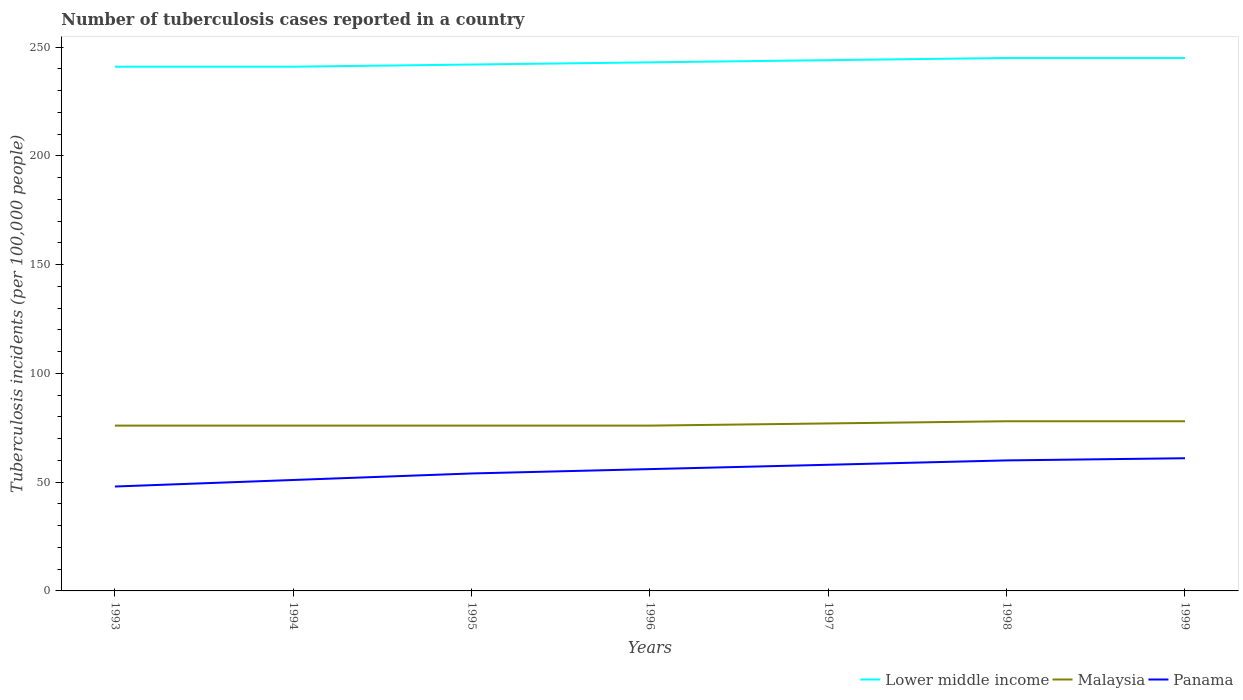Does the line corresponding to Panama intersect with the line corresponding to Malaysia?
Give a very brief answer. No. Across all years, what is the maximum number of tuberculosis cases reported in in Malaysia?
Offer a terse response. 76. In which year was the number of tuberculosis cases reported in in Panama maximum?
Offer a very short reply. 1993. What is the total number of tuberculosis cases reported in in Lower middle income in the graph?
Give a very brief answer. -3. What is the difference between the highest and the second highest number of tuberculosis cases reported in in Panama?
Ensure brevity in your answer.  13. What is the difference between the highest and the lowest number of tuberculosis cases reported in in Lower middle income?
Offer a very short reply. 3. Is the number of tuberculosis cases reported in in Malaysia strictly greater than the number of tuberculosis cases reported in in Panama over the years?
Your response must be concise. No. What is the difference between two consecutive major ticks on the Y-axis?
Offer a terse response. 50. Are the values on the major ticks of Y-axis written in scientific E-notation?
Offer a terse response. No. Does the graph contain any zero values?
Your answer should be very brief. No. Does the graph contain grids?
Ensure brevity in your answer.  No. How many legend labels are there?
Your response must be concise. 3. How are the legend labels stacked?
Provide a short and direct response. Horizontal. What is the title of the graph?
Offer a very short reply. Number of tuberculosis cases reported in a country. What is the label or title of the X-axis?
Provide a short and direct response. Years. What is the label or title of the Y-axis?
Make the answer very short. Tuberculosis incidents (per 100,0 people). What is the Tuberculosis incidents (per 100,000 people) in Lower middle income in 1993?
Make the answer very short. 241. What is the Tuberculosis incidents (per 100,000 people) of Panama in 1993?
Provide a short and direct response. 48. What is the Tuberculosis incidents (per 100,000 people) of Lower middle income in 1994?
Your answer should be compact. 241. What is the Tuberculosis incidents (per 100,000 people) in Lower middle income in 1995?
Offer a terse response. 242. What is the Tuberculosis incidents (per 100,000 people) in Malaysia in 1995?
Offer a very short reply. 76. What is the Tuberculosis incidents (per 100,000 people) of Lower middle income in 1996?
Ensure brevity in your answer.  243. What is the Tuberculosis incidents (per 100,000 people) of Malaysia in 1996?
Offer a very short reply. 76. What is the Tuberculosis incidents (per 100,000 people) in Lower middle income in 1997?
Give a very brief answer. 244. What is the Tuberculosis incidents (per 100,000 people) in Panama in 1997?
Your answer should be very brief. 58. What is the Tuberculosis incidents (per 100,000 people) in Lower middle income in 1998?
Provide a short and direct response. 245. What is the Tuberculosis incidents (per 100,000 people) in Malaysia in 1998?
Offer a very short reply. 78. What is the Tuberculosis incidents (per 100,000 people) in Lower middle income in 1999?
Your answer should be compact. 245. What is the Tuberculosis incidents (per 100,000 people) of Panama in 1999?
Your answer should be compact. 61. Across all years, what is the maximum Tuberculosis incidents (per 100,000 people) of Lower middle income?
Keep it short and to the point. 245. Across all years, what is the minimum Tuberculosis incidents (per 100,000 people) of Lower middle income?
Offer a very short reply. 241. Across all years, what is the minimum Tuberculosis incidents (per 100,000 people) of Malaysia?
Provide a short and direct response. 76. Across all years, what is the minimum Tuberculosis incidents (per 100,000 people) in Panama?
Make the answer very short. 48. What is the total Tuberculosis incidents (per 100,000 people) of Lower middle income in the graph?
Provide a short and direct response. 1701. What is the total Tuberculosis incidents (per 100,000 people) in Malaysia in the graph?
Offer a very short reply. 537. What is the total Tuberculosis incidents (per 100,000 people) of Panama in the graph?
Give a very brief answer. 388. What is the difference between the Tuberculosis incidents (per 100,000 people) in Lower middle income in 1993 and that in 1994?
Make the answer very short. 0. What is the difference between the Tuberculosis incidents (per 100,000 people) of Malaysia in 1993 and that in 1994?
Your response must be concise. 0. What is the difference between the Tuberculosis incidents (per 100,000 people) in Malaysia in 1993 and that in 1995?
Give a very brief answer. 0. What is the difference between the Tuberculosis incidents (per 100,000 people) in Panama in 1993 and that in 1995?
Provide a short and direct response. -6. What is the difference between the Tuberculosis incidents (per 100,000 people) of Malaysia in 1993 and that in 1996?
Offer a very short reply. 0. What is the difference between the Tuberculosis incidents (per 100,000 people) in Lower middle income in 1993 and that in 1997?
Offer a very short reply. -3. What is the difference between the Tuberculosis incidents (per 100,000 people) of Malaysia in 1993 and that in 1997?
Keep it short and to the point. -1. What is the difference between the Tuberculosis incidents (per 100,000 people) in Malaysia in 1993 and that in 1998?
Offer a very short reply. -2. What is the difference between the Tuberculosis incidents (per 100,000 people) in Lower middle income in 1993 and that in 1999?
Provide a succinct answer. -4. What is the difference between the Tuberculosis incidents (per 100,000 people) of Malaysia in 1993 and that in 1999?
Offer a very short reply. -2. What is the difference between the Tuberculosis incidents (per 100,000 people) of Panama in 1993 and that in 1999?
Keep it short and to the point. -13. What is the difference between the Tuberculosis incidents (per 100,000 people) of Panama in 1994 and that in 1995?
Provide a succinct answer. -3. What is the difference between the Tuberculosis incidents (per 100,000 people) of Lower middle income in 1994 and that in 1996?
Your answer should be very brief. -2. What is the difference between the Tuberculosis incidents (per 100,000 people) in Malaysia in 1994 and that in 1996?
Give a very brief answer. 0. What is the difference between the Tuberculosis incidents (per 100,000 people) of Panama in 1994 and that in 1997?
Offer a very short reply. -7. What is the difference between the Tuberculosis incidents (per 100,000 people) of Panama in 1994 and that in 1999?
Offer a terse response. -10. What is the difference between the Tuberculosis incidents (per 100,000 people) of Malaysia in 1995 and that in 1996?
Provide a succinct answer. 0. What is the difference between the Tuberculosis incidents (per 100,000 people) in Lower middle income in 1995 and that in 1997?
Provide a short and direct response. -2. What is the difference between the Tuberculosis incidents (per 100,000 people) in Panama in 1995 and that in 1997?
Offer a terse response. -4. What is the difference between the Tuberculosis incidents (per 100,000 people) of Lower middle income in 1995 and that in 1998?
Your answer should be very brief. -3. What is the difference between the Tuberculosis incidents (per 100,000 people) of Malaysia in 1995 and that in 1998?
Your response must be concise. -2. What is the difference between the Tuberculosis incidents (per 100,000 people) of Lower middle income in 1995 and that in 1999?
Provide a short and direct response. -3. What is the difference between the Tuberculosis incidents (per 100,000 people) of Panama in 1995 and that in 1999?
Ensure brevity in your answer.  -7. What is the difference between the Tuberculosis incidents (per 100,000 people) of Lower middle income in 1996 and that in 1997?
Your answer should be compact. -1. What is the difference between the Tuberculosis incidents (per 100,000 people) in Lower middle income in 1996 and that in 1998?
Make the answer very short. -2. What is the difference between the Tuberculosis incidents (per 100,000 people) in Malaysia in 1996 and that in 1998?
Provide a succinct answer. -2. What is the difference between the Tuberculosis incidents (per 100,000 people) of Panama in 1996 and that in 1998?
Keep it short and to the point. -4. What is the difference between the Tuberculosis incidents (per 100,000 people) in Lower middle income in 1996 and that in 1999?
Your answer should be compact. -2. What is the difference between the Tuberculosis incidents (per 100,000 people) of Malaysia in 1996 and that in 1999?
Your answer should be compact. -2. What is the difference between the Tuberculosis incidents (per 100,000 people) of Panama in 1996 and that in 1999?
Your response must be concise. -5. What is the difference between the Tuberculosis incidents (per 100,000 people) in Lower middle income in 1997 and that in 1998?
Give a very brief answer. -1. What is the difference between the Tuberculosis incidents (per 100,000 people) of Malaysia in 1997 and that in 1999?
Give a very brief answer. -1. What is the difference between the Tuberculosis incidents (per 100,000 people) in Panama in 1997 and that in 1999?
Ensure brevity in your answer.  -3. What is the difference between the Tuberculosis incidents (per 100,000 people) of Lower middle income in 1998 and that in 1999?
Your answer should be very brief. 0. What is the difference between the Tuberculosis incidents (per 100,000 people) in Malaysia in 1998 and that in 1999?
Offer a terse response. 0. What is the difference between the Tuberculosis incidents (per 100,000 people) in Lower middle income in 1993 and the Tuberculosis incidents (per 100,000 people) in Malaysia in 1994?
Your response must be concise. 165. What is the difference between the Tuberculosis incidents (per 100,000 people) in Lower middle income in 1993 and the Tuberculosis incidents (per 100,000 people) in Panama in 1994?
Offer a very short reply. 190. What is the difference between the Tuberculosis incidents (per 100,000 people) in Malaysia in 1993 and the Tuberculosis incidents (per 100,000 people) in Panama in 1994?
Keep it short and to the point. 25. What is the difference between the Tuberculosis incidents (per 100,000 people) of Lower middle income in 1993 and the Tuberculosis incidents (per 100,000 people) of Malaysia in 1995?
Give a very brief answer. 165. What is the difference between the Tuberculosis incidents (per 100,000 people) of Lower middle income in 1993 and the Tuberculosis incidents (per 100,000 people) of Panama in 1995?
Provide a succinct answer. 187. What is the difference between the Tuberculosis incidents (per 100,000 people) of Malaysia in 1993 and the Tuberculosis incidents (per 100,000 people) of Panama in 1995?
Offer a very short reply. 22. What is the difference between the Tuberculosis incidents (per 100,000 people) in Lower middle income in 1993 and the Tuberculosis incidents (per 100,000 people) in Malaysia in 1996?
Offer a very short reply. 165. What is the difference between the Tuberculosis incidents (per 100,000 people) of Lower middle income in 1993 and the Tuberculosis incidents (per 100,000 people) of Panama in 1996?
Provide a short and direct response. 185. What is the difference between the Tuberculosis incidents (per 100,000 people) of Lower middle income in 1993 and the Tuberculosis incidents (per 100,000 people) of Malaysia in 1997?
Offer a very short reply. 164. What is the difference between the Tuberculosis incidents (per 100,000 people) of Lower middle income in 1993 and the Tuberculosis incidents (per 100,000 people) of Panama in 1997?
Your answer should be very brief. 183. What is the difference between the Tuberculosis incidents (per 100,000 people) in Lower middle income in 1993 and the Tuberculosis incidents (per 100,000 people) in Malaysia in 1998?
Your answer should be very brief. 163. What is the difference between the Tuberculosis incidents (per 100,000 people) of Lower middle income in 1993 and the Tuberculosis incidents (per 100,000 people) of Panama in 1998?
Make the answer very short. 181. What is the difference between the Tuberculosis incidents (per 100,000 people) in Malaysia in 1993 and the Tuberculosis incidents (per 100,000 people) in Panama in 1998?
Your answer should be very brief. 16. What is the difference between the Tuberculosis incidents (per 100,000 people) in Lower middle income in 1993 and the Tuberculosis incidents (per 100,000 people) in Malaysia in 1999?
Give a very brief answer. 163. What is the difference between the Tuberculosis incidents (per 100,000 people) in Lower middle income in 1993 and the Tuberculosis incidents (per 100,000 people) in Panama in 1999?
Your answer should be very brief. 180. What is the difference between the Tuberculosis incidents (per 100,000 people) in Malaysia in 1993 and the Tuberculosis incidents (per 100,000 people) in Panama in 1999?
Offer a very short reply. 15. What is the difference between the Tuberculosis incidents (per 100,000 people) of Lower middle income in 1994 and the Tuberculosis incidents (per 100,000 people) of Malaysia in 1995?
Provide a short and direct response. 165. What is the difference between the Tuberculosis incidents (per 100,000 people) of Lower middle income in 1994 and the Tuberculosis incidents (per 100,000 people) of Panama in 1995?
Give a very brief answer. 187. What is the difference between the Tuberculosis incidents (per 100,000 people) of Lower middle income in 1994 and the Tuberculosis incidents (per 100,000 people) of Malaysia in 1996?
Give a very brief answer. 165. What is the difference between the Tuberculosis incidents (per 100,000 people) in Lower middle income in 1994 and the Tuberculosis incidents (per 100,000 people) in Panama in 1996?
Keep it short and to the point. 185. What is the difference between the Tuberculosis incidents (per 100,000 people) of Lower middle income in 1994 and the Tuberculosis incidents (per 100,000 people) of Malaysia in 1997?
Offer a terse response. 164. What is the difference between the Tuberculosis incidents (per 100,000 people) in Lower middle income in 1994 and the Tuberculosis incidents (per 100,000 people) in Panama in 1997?
Keep it short and to the point. 183. What is the difference between the Tuberculosis incidents (per 100,000 people) of Lower middle income in 1994 and the Tuberculosis incidents (per 100,000 people) of Malaysia in 1998?
Provide a short and direct response. 163. What is the difference between the Tuberculosis incidents (per 100,000 people) of Lower middle income in 1994 and the Tuberculosis incidents (per 100,000 people) of Panama in 1998?
Make the answer very short. 181. What is the difference between the Tuberculosis incidents (per 100,000 people) in Lower middle income in 1994 and the Tuberculosis incidents (per 100,000 people) in Malaysia in 1999?
Your answer should be very brief. 163. What is the difference between the Tuberculosis incidents (per 100,000 people) of Lower middle income in 1994 and the Tuberculosis incidents (per 100,000 people) of Panama in 1999?
Your response must be concise. 180. What is the difference between the Tuberculosis incidents (per 100,000 people) in Malaysia in 1994 and the Tuberculosis incidents (per 100,000 people) in Panama in 1999?
Offer a terse response. 15. What is the difference between the Tuberculosis incidents (per 100,000 people) of Lower middle income in 1995 and the Tuberculosis incidents (per 100,000 people) of Malaysia in 1996?
Make the answer very short. 166. What is the difference between the Tuberculosis incidents (per 100,000 people) in Lower middle income in 1995 and the Tuberculosis incidents (per 100,000 people) in Panama in 1996?
Offer a terse response. 186. What is the difference between the Tuberculosis incidents (per 100,000 people) in Lower middle income in 1995 and the Tuberculosis incidents (per 100,000 people) in Malaysia in 1997?
Your response must be concise. 165. What is the difference between the Tuberculosis incidents (per 100,000 people) in Lower middle income in 1995 and the Tuberculosis incidents (per 100,000 people) in Panama in 1997?
Your response must be concise. 184. What is the difference between the Tuberculosis incidents (per 100,000 people) of Lower middle income in 1995 and the Tuberculosis incidents (per 100,000 people) of Malaysia in 1998?
Ensure brevity in your answer.  164. What is the difference between the Tuberculosis incidents (per 100,000 people) of Lower middle income in 1995 and the Tuberculosis incidents (per 100,000 people) of Panama in 1998?
Your answer should be very brief. 182. What is the difference between the Tuberculosis incidents (per 100,000 people) in Malaysia in 1995 and the Tuberculosis incidents (per 100,000 people) in Panama in 1998?
Your answer should be compact. 16. What is the difference between the Tuberculosis incidents (per 100,000 people) of Lower middle income in 1995 and the Tuberculosis incidents (per 100,000 people) of Malaysia in 1999?
Offer a very short reply. 164. What is the difference between the Tuberculosis incidents (per 100,000 people) in Lower middle income in 1995 and the Tuberculosis incidents (per 100,000 people) in Panama in 1999?
Provide a succinct answer. 181. What is the difference between the Tuberculosis incidents (per 100,000 people) of Malaysia in 1995 and the Tuberculosis incidents (per 100,000 people) of Panama in 1999?
Offer a very short reply. 15. What is the difference between the Tuberculosis incidents (per 100,000 people) in Lower middle income in 1996 and the Tuberculosis incidents (per 100,000 people) in Malaysia in 1997?
Your answer should be very brief. 166. What is the difference between the Tuberculosis incidents (per 100,000 people) in Lower middle income in 1996 and the Tuberculosis incidents (per 100,000 people) in Panama in 1997?
Keep it short and to the point. 185. What is the difference between the Tuberculosis incidents (per 100,000 people) of Lower middle income in 1996 and the Tuberculosis incidents (per 100,000 people) of Malaysia in 1998?
Ensure brevity in your answer.  165. What is the difference between the Tuberculosis incidents (per 100,000 people) of Lower middle income in 1996 and the Tuberculosis incidents (per 100,000 people) of Panama in 1998?
Offer a very short reply. 183. What is the difference between the Tuberculosis incidents (per 100,000 people) in Malaysia in 1996 and the Tuberculosis incidents (per 100,000 people) in Panama in 1998?
Offer a terse response. 16. What is the difference between the Tuberculosis incidents (per 100,000 people) of Lower middle income in 1996 and the Tuberculosis incidents (per 100,000 people) of Malaysia in 1999?
Offer a terse response. 165. What is the difference between the Tuberculosis incidents (per 100,000 people) in Lower middle income in 1996 and the Tuberculosis incidents (per 100,000 people) in Panama in 1999?
Offer a very short reply. 182. What is the difference between the Tuberculosis incidents (per 100,000 people) in Lower middle income in 1997 and the Tuberculosis incidents (per 100,000 people) in Malaysia in 1998?
Give a very brief answer. 166. What is the difference between the Tuberculosis incidents (per 100,000 people) in Lower middle income in 1997 and the Tuberculosis incidents (per 100,000 people) in Panama in 1998?
Offer a terse response. 184. What is the difference between the Tuberculosis incidents (per 100,000 people) of Malaysia in 1997 and the Tuberculosis incidents (per 100,000 people) of Panama in 1998?
Ensure brevity in your answer.  17. What is the difference between the Tuberculosis incidents (per 100,000 people) in Lower middle income in 1997 and the Tuberculosis incidents (per 100,000 people) in Malaysia in 1999?
Provide a succinct answer. 166. What is the difference between the Tuberculosis incidents (per 100,000 people) of Lower middle income in 1997 and the Tuberculosis incidents (per 100,000 people) of Panama in 1999?
Your answer should be compact. 183. What is the difference between the Tuberculosis incidents (per 100,000 people) in Lower middle income in 1998 and the Tuberculosis incidents (per 100,000 people) in Malaysia in 1999?
Keep it short and to the point. 167. What is the difference between the Tuberculosis incidents (per 100,000 people) in Lower middle income in 1998 and the Tuberculosis incidents (per 100,000 people) in Panama in 1999?
Your answer should be very brief. 184. What is the difference between the Tuberculosis incidents (per 100,000 people) in Malaysia in 1998 and the Tuberculosis incidents (per 100,000 people) in Panama in 1999?
Offer a very short reply. 17. What is the average Tuberculosis incidents (per 100,000 people) of Lower middle income per year?
Keep it short and to the point. 243. What is the average Tuberculosis incidents (per 100,000 people) of Malaysia per year?
Your response must be concise. 76.71. What is the average Tuberculosis incidents (per 100,000 people) in Panama per year?
Make the answer very short. 55.43. In the year 1993, what is the difference between the Tuberculosis incidents (per 100,000 people) of Lower middle income and Tuberculosis incidents (per 100,000 people) of Malaysia?
Give a very brief answer. 165. In the year 1993, what is the difference between the Tuberculosis incidents (per 100,000 people) of Lower middle income and Tuberculosis incidents (per 100,000 people) of Panama?
Provide a succinct answer. 193. In the year 1993, what is the difference between the Tuberculosis incidents (per 100,000 people) in Malaysia and Tuberculosis incidents (per 100,000 people) in Panama?
Your answer should be compact. 28. In the year 1994, what is the difference between the Tuberculosis incidents (per 100,000 people) in Lower middle income and Tuberculosis incidents (per 100,000 people) in Malaysia?
Offer a terse response. 165. In the year 1994, what is the difference between the Tuberculosis incidents (per 100,000 people) in Lower middle income and Tuberculosis incidents (per 100,000 people) in Panama?
Offer a very short reply. 190. In the year 1995, what is the difference between the Tuberculosis incidents (per 100,000 people) of Lower middle income and Tuberculosis incidents (per 100,000 people) of Malaysia?
Provide a succinct answer. 166. In the year 1995, what is the difference between the Tuberculosis incidents (per 100,000 people) in Lower middle income and Tuberculosis incidents (per 100,000 people) in Panama?
Your answer should be very brief. 188. In the year 1995, what is the difference between the Tuberculosis incidents (per 100,000 people) of Malaysia and Tuberculosis incidents (per 100,000 people) of Panama?
Your answer should be compact. 22. In the year 1996, what is the difference between the Tuberculosis incidents (per 100,000 people) in Lower middle income and Tuberculosis incidents (per 100,000 people) in Malaysia?
Your answer should be very brief. 167. In the year 1996, what is the difference between the Tuberculosis incidents (per 100,000 people) of Lower middle income and Tuberculosis incidents (per 100,000 people) of Panama?
Offer a very short reply. 187. In the year 1996, what is the difference between the Tuberculosis incidents (per 100,000 people) in Malaysia and Tuberculosis incidents (per 100,000 people) in Panama?
Provide a succinct answer. 20. In the year 1997, what is the difference between the Tuberculosis incidents (per 100,000 people) of Lower middle income and Tuberculosis incidents (per 100,000 people) of Malaysia?
Provide a short and direct response. 167. In the year 1997, what is the difference between the Tuberculosis incidents (per 100,000 people) of Lower middle income and Tuberculosis incidents (per 100,000 people) of Panama?
Your answer should be very brief. 186. In the year 1997, what is the difference between the Tuberculosis incidents (per 100,000 people) of Malaysia and Tuberculosis incidents (per 100,000 people) of Panama?
Your response must be concise. 19. In the year 1998, what is the difference between the Tuberculosis incidents (per 100,000 people) of Lower middle income and Tuberculosis incidents (per 100,000 people) of Malaysia?
Provide a short and direct response. 167. In the year 1998, what is the difference between the Tuberculosis incidents (per 100,000 people) in Lower middle income and Tuberculosis incidents (per 100,000 people) in Panama?
Your answer should be very brief. 185. In the year 1999, what is the difference between the Tuberculosis incidents (per 100,000 people) of Lower middle income and Tuberculosis incidents (per 100,000 people) of Malaysia?
Your answer should be compact. 167. In the year 1999, what is the difference between the Tuberculosis incidents (per 100,000 people) in Lower middle income and Tuberculosis incidents (per 100,000 people) in Panama?
Offer a terse response. 184. In the year 1999, what is the difference between the Tuberculosis incidents (per 100,000 people) of Malaysia and Tuberculosis incidents (per 100,000 people) of Panama?
Give a very brief answer. 17. What is the ratio of the Tuberculosis incidents (per 100,000 people) in Lower middle income in 1993 to that in 1994?
Keep it short and to the point. 1. What is the ratio of the Tuberculosis incidents (per 100,000 people) in Malaysia in 1993 to that in 1994?
Your answer should be very brief. 1. What is the ratio of the Tuberculosis incidents (per 100,000 people) in Panama in 1993 to that in 1994?
Your response must be concise. 0.94. What is the ratio of the Tuberculosis incidents (per 100,000 people) in Lower middle income in 1993 to that in 1995?
Offer a terse response. 1. What is the ratio of the Tuberculosis incidents (per 100,000 people) in Panama in 1993 to that in 1995?
Provide a succinct answer. 0.89. What is the ratio of the Tuberculosis incidents (per 100,000 people) in Panama in 1993 to that in 1996?
Provide a short and direct response. 0.86. What is the ratio of the Tuberculosis incidents (per 100,000 people) in Lower middle income in 1993 to that in 1997?
Keep it short and to the point. 0.99. What is the ratio of the Tuberculosis incidents (per 100,000 people) of Malaysia in 1993 to that in 1997?
Ensure brevity in your answer.  0.99. What is the ratio of the Tuberculosis incidents (per 100,000 people) of Panama in 1993 to that in 1997?
Offer a terse response. 0.83. What is the ratio of the Tuberculosis incidents (per 100,000 people) in Lower middle income in 1993 to that in 1998?
Your response must be concise. 0.98. What is the ratio of the Tuberculosis incidents (per 100,000 people) in Malaysia in 1993 to that in 1998?
Make the answer very short. 0.97. What is the ratio of the Tuberculosis incidents (per 100,000 people) in Lower middle income in 1993 to that in 1999?
Your answer should be very brief. 0.98. What is the ratio of the Tuberculosis incidents (per 100,000 people) in Malaysia in 1993 to that in 1999?
Offer a terse response. 0.97. What is the ratio of the Tuberculosis incidents (per 100,000 people) of Panama in 1993 to that in 1999?
Offer a terse response. 0.79. What is the ratio of the Tuberculosis incidents (per 100,000 people) of Lower middle income in 1994 to that in 1995?
Offer a terse response. 1. What is the ratio of the Tuberculosis incidents (per 100,000 people) in Panama in 1994 to that in 1995?
Give a very brief answer. 0.94. What is the ratio of the Tuberculosis incidents (per 100,000 people) of Lower middle income in 1994 to that in 1996?
Ensure brevity in your answer.  0.99. What is the ratio of the Tuberculosis incidents (per 100,000 people) in Panama in 1994 to that in 1996?
Give a very brief answer. 0.91. What is the ratio of the Tuberculosis incidents (per 100,000 people) of Panama in 1994 to that in 1997?
Ensure brevity in your answer.  0.88. What is the ratio of the Tuberculosis incidents (per 100,000 people) in Lower middle income in 1994 to that in 1998?
Make the answer very short. 0.98. What is the ratio of the Tuberculosis incidents (per 100,000 people) in Malaysia in 1994 to that in 1998?
Provide a short and direct response. 0.97. What is the ratio of the Tuberculosis incidents (per 100,000 people) of Lower middle income in 1994 to that in 1999?
Your answer should be compact. 0.98. What is the ratio of the Tuberculosis incidents (per 100,000 people) of Malaysia in 1994 to that in 1999?
Offer a terse response. 0.97. What is the ratio of the Tuberculosis incidents (per 100,000 people) in Panama in 1994 to that in 1999?
Give a very brief answer. 0.84. What is the ratio of the Tuberculosis incidents (per 100,000 people) in Panama in 1995 to that in 1996?
Keep it short and to the point. 0.96. What is the ratio of the Tuberculosis incidents (per 100,000 people) in Lower middle income in 1995 to that in 1997?
Your answer should be very brief. 0.99. What is the ratio of the Tuberculosis incidents (per 100,000 people) in Panama in 1995 to that in 1997?
Provide a short and direct response. 0.93. What is the ratio of the Tuberculosis incidents (per 100,000 people) of Lower middle income in 1995 to that in 1998?
Make the answer very short. 0.99. What is the ratio of the Tuberculosis incidents (per 100,000 people) of Malaysia in 1995 to that in 1998?
Provide a succinct answer. 0.97. What is the ratio of the Tuberculosis incidents (per 100,000 people) of Panama in 1995 to that in 1998?
Offer a terse response. 0.9. What is the ratio of the Tuberculosis incidents (per 100,000 people) of Lower middle income in 1995 to that in 1999?
Your answer should be very brief. 0.99. What is the ratio of the Tuberculosis incidents (per 100,000 people) of Malaysia in 1995 to that in 1999?
Your response must be concise. 0.97. What is the ratio of the Tuberculosis incidents (per 100,000 people) in Panama in 1995 to that in 1999?
Give a very brief answer. 0.89. What is the ratio of the Tuberculosis incidents (per 100,000 people) of Lower middle income in 1996 to that in 1997?
Provide a succinct answer. 1. What is the ratio of the Tuberculosis incidents (per 100,000 people) in Malaysia in 1996 to that in 1997?
Offer a very short reply. 0.99. What is the ratio of the Tuberculosis incidents (per 100,000 people) of Panama in 1996 to that in 1997?
Offer a terse response. 0.97. What is the ratio of the Tuberculosis incidents (per 100,000 people) of Malaysia in 1996 to that in 1998?
Give a very brief answer. 0.97. What is the ratio of the Tuberculosis incidents (per 100,000 people) in Lower middle income in 1996 to that in 1999?
Your response must be concise. 0.99. What is the ratio of the Tuberculosis incidents (per 100,000 people) in Malaysia in 1996 to that in 1999?
Your answer should be compact. 0.97. What is the ratio of the Tuberculosis incidents (per 100,000 people) of Panama in 1996 to that in 1999?
Your answer should be compact. 0.92. What is the ratio of the Tuberculosis incidents (per 100,000 people) in Lower middle income in 1997 to that in 1998?
Your answer should be very brief. 1. What is the ratio of the Tuberculosis incidents (per 100,000 people) in Malaysia in 1997 to that in 1998?
Provide a succinct answer. 0.99. What is the ratio of the Tuberculosis incidents (per 100,000 people) in Panama in 1997 to that in 1998?
Provide a short and direct response. 0.97. What is the ratio of the Tuberculosis incidents (per 100,000 people) of Lower middle income in 1997 to that in 1999?
Provide a short and direct response. 1. What is the ratio of the Tuberculosis incidents (per 100,000 people) of Malaysia in 1997 to that in 1999?
Your answer should be very brief. 0.99. What is the ratio of the Tuberculosis incidents (per 100,000 people) of Panama in 1997 to that in 1999?
Ensure brevity in your answer.  0.95. What is the ratio of the Tuberculosis incidents (per 100,000 people) of Lower middle income in 1998 to that in 1999?
Offer a very short reply. 1. What is the ratio of the Tuberculosis incidents (per 100,000 people) of Panama in 1998 to that in 1999?
Offer a very short reply. 0.98. What is the difference between the highest and the lowest Tuberculosis incidents (per 100,000 people) of Lower middle income?
Your answer should be very brief. 4. What is the difference between the highest and the lowest Tuberculosis incidents (per 100,000 people) in Malaysia?
Your response must be concise. 2. What is the difference between the highest and the lowest Tuberculosis incidents (per 100,000 people) in Panama?
Make the answer very short. 13. 